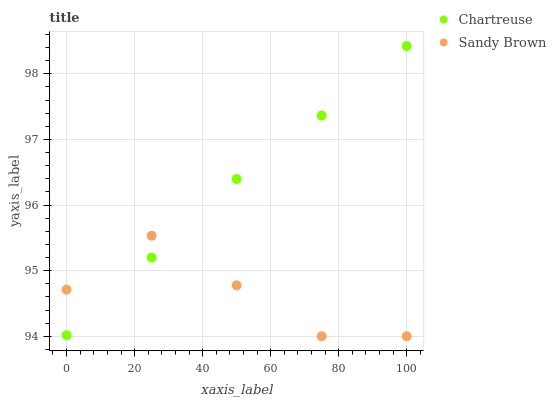Does Sandy Brown have the minimum area under the curve?
Answer yes or no. Yes. Does Chartreuse have the maximum area under the curve?
Answer yes or no. Yes. Does Sandy Brown have the maximum area under the curve?
Answer yes or no. No. Is Chartreuse the smoothest?
Answer yes or no. Yes. Is Sandy Brown the roughest?
Answer yes or no. Yes. Is Sandy Brown the smoothest?
Answer yes or no. No. Does Sandy Brown have the lowest value?
Answer yes or no. Yes. Does Chartreuse have the highest value?
Answer yes or no. Yes. Does Sandy Brown have the highest value?
Answer yes or no. No. Does Sandy Brown intersect Chartreuse?
Answer yes or no. Yes. Is Sandy Brown less than Chartreuse?
Answer yes or no. No. Is Sandy Brown greater than Chartreuse?
Answer yes or no. No. 